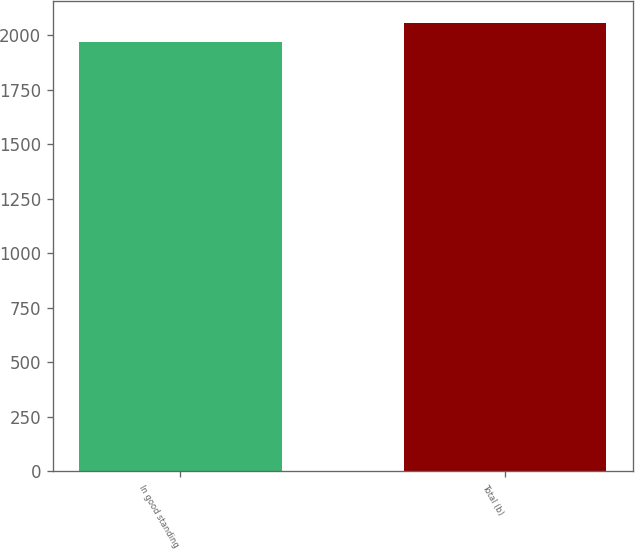<chart> <loc_0><loc_0><loc_500><loc_500><bar_chart><fcel>In good standing<fcel>Total (b)<nl><fcel>1970<fcel>2055<nl></chart> 